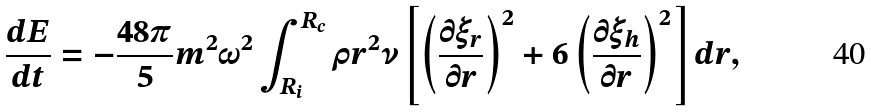<formula> <loc_0><loc_0><loc_500><loc_500>\frac { d E } { d t } = - \frac { 4 8 \pi } { 5 } m ^ { 2 } \omega ^ { 2 } \int _ { R _ { i } } ^ { R _ { c } } \rho r ^ { 2 } \nu \left [ \left ( \frac { \partial \xi _ { r } } { \partial r } \right ) ^ { 2 } + 6 \left ( \frac { \partial \xi _ { h } } { \partial r } \right ) ^ { 2 } \right ] d r ,</formula> 